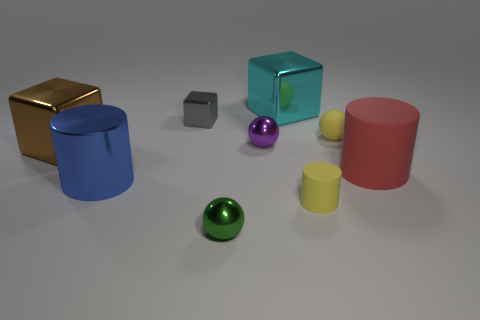Add 1 big things. How many objects exist? 10 Subtract all blocks. How many objects are left? 6 Add 9 purple balls. How many purple balls are left? 10 Add 6 large blue objects. How many large blue objects exist? 7 Subtract 0 purple blocks. How many objects are left? 9 Subtract all cyan shiny things. Subtract all tiny gray shiny things. How many objects are left? 7 